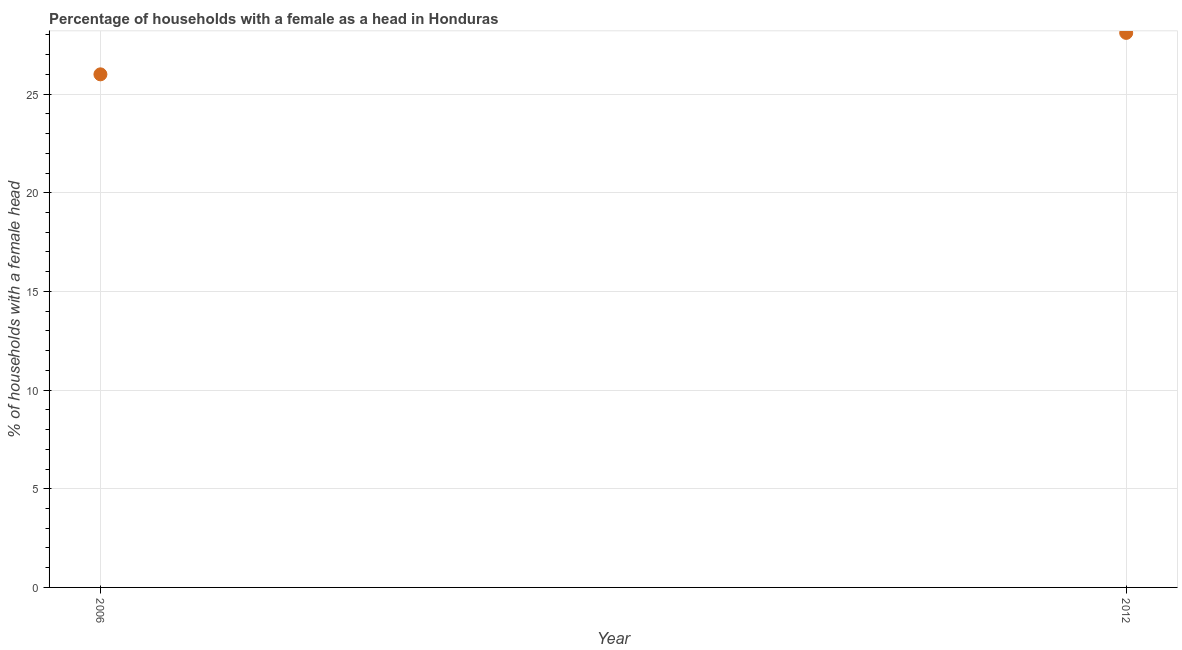Across all years, what is the maximum number of female supervised households?
Offer a very short reply. 28.1. Across all years, what is the minimum number of female supervised households?
Keep it short and to the point. 26. In which year was the number of female supervised households minimum?
Your answer should be compact. 2006. What is the sum of the number of female supervised households?
Provide a short and direct response. 54.1. What is the difference between the number of female supervised households in 2006 and 2012?
Provide a short and direct response. -2.1. What is the average number of female supervised households per year?
Provide a short and direct response. 27.05. What is the median number of female supervised households?
Ensure brevity in your answer.  27.05. What is the ratio of the number of female supervised households in 2006 to that in 2012?
Make the answer very short. 0.93. Is the number of female supervised households in 2006 less than that in 2012?
Your answer should be compact. Yes. In how many years, is the number of female supervised households greater than the average number of female supervised households taken over all years?
Ensure brevity in your answer.  1. Does the number of female supervised households monotonically increase over the years?
Offer a terse response. Yes. What is the difference between two consecutive major ticks on the Y-axis?
Your answer should be very brief. 5. What is the title of the graph?
Offer a terse response. Percentage of households with a female as a head in Honduras. What is the label or title of the Y-axis?
Your response must be concise. % of households with a female head. What is the % of households with a female head in 2006?
Ensure brevity in your answer.  26. What is the % of households with a female head in 2012?
Offer a very short reply. 28.1. What is the difference between the % of households with a female head in 2006 and 2012?
Offer a terse response. -2.1. What is the ratio of the % of households with a female head in 2006 to that in 2012?
Offer a very short reply. 0.93. 